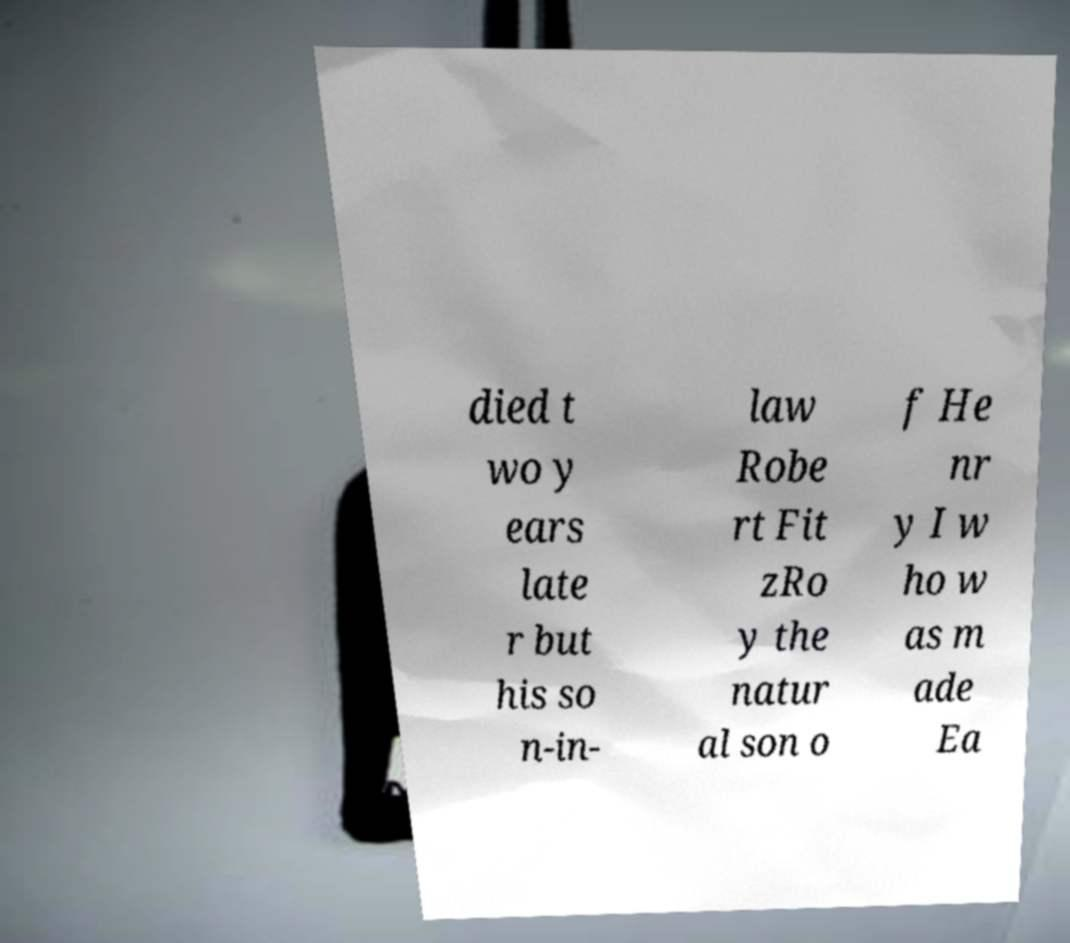What messages or text are displayed in this image? I need them in a readable, typed format. died t wo y ears late r but his so n-in- law Robe rt Fit zRo y the natur al son o f He nr y I w ho w as m ade Ea 